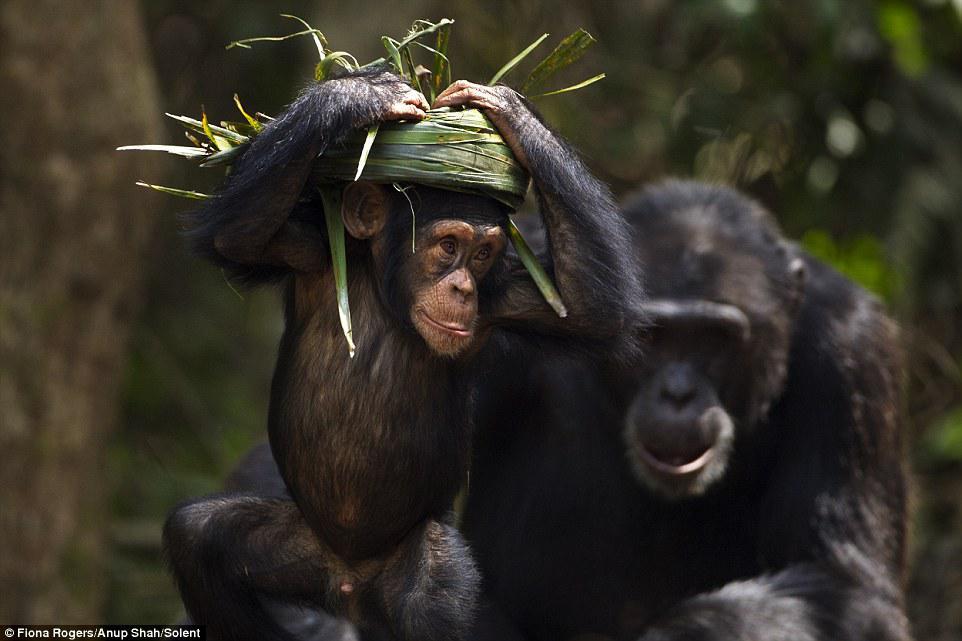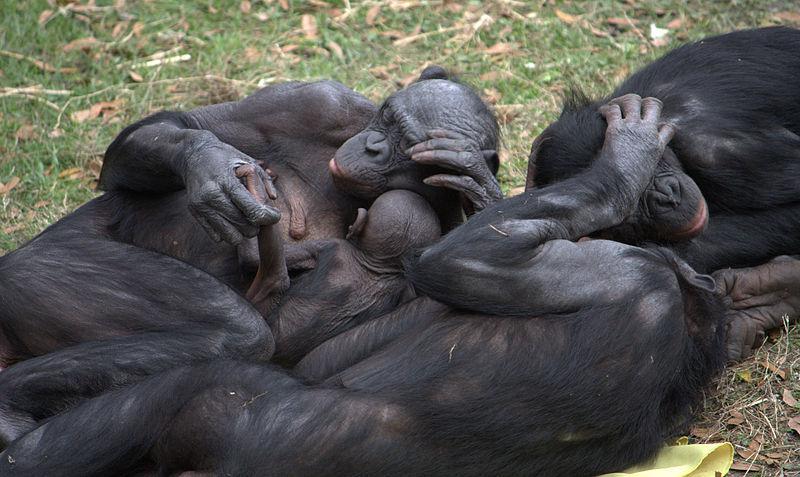The first image is the image on the left, the second image is the image on the right. For the images displayed, is the sentence "One image includes an adult chimp lying on its side face-to-face with a baby chimp and holding the baby chimp's leg." factually correct? Answer yes or no. Yes. The first image is the image on the left, the second image is the image on the right. For the images shown, is this caption "Six chimps can be seen" true? Answer yes or no. Yes. 